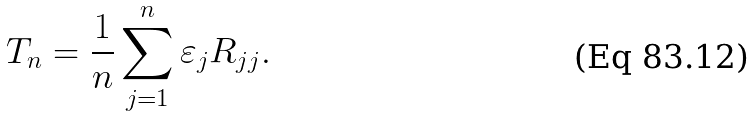<formula> <loc_0><loc_0><loc_500><loc_500>T _ { n } = \frac { 1 } { n } \sum _ { j = 1 } ^ { n } \varepsilon _ { j } R _ { j j } .</formula> 